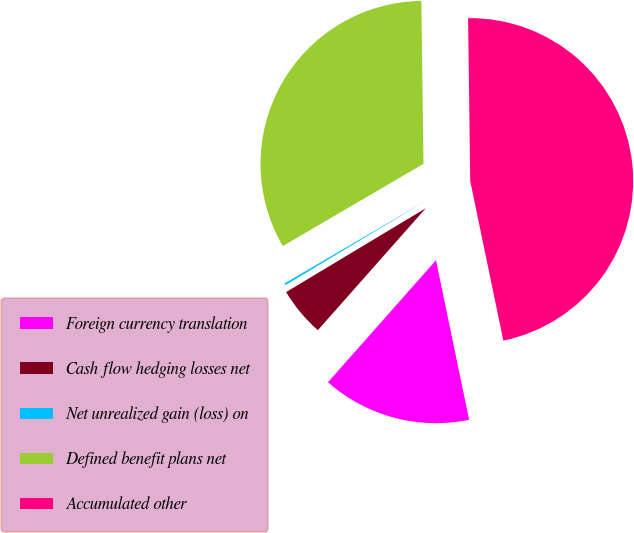Convert chart. <chart><loc_0><loc_0><loc_500><loc_500><pie_chart><fcel>Foreign currency translation<fcel>Cash flow hedging losses net<fcel>Net unrealized gain (loss) on<fcel>Defined benefit plans net<fcel>Accumulated other<nl><fcel>14.79%<fcel>4.86%<fcel>0.19%<fcel>33.21%<fcel>46.95%<nl></chart> 